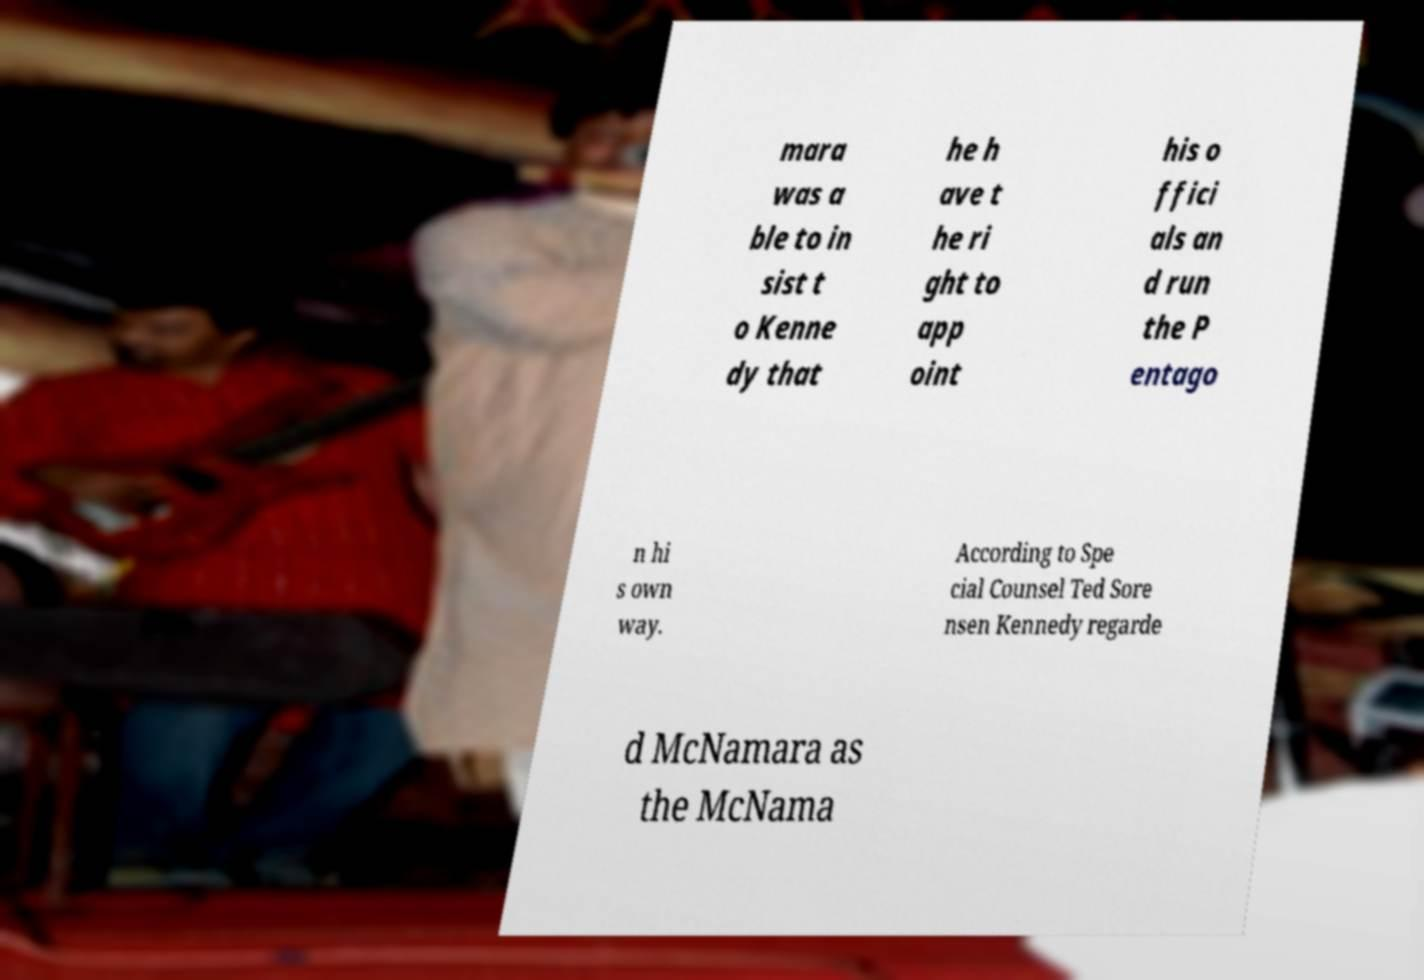Please read and relay the text visible in this image. What does it say? mara was a ble to in sist t o Kenne dy that he h ave t he ri ght to app oint his o ffici als an d run the P entago n hi s own way. According to Spe cial Counsel Ted Sore nsen Kennedy regarde d McNamara as the McNama 